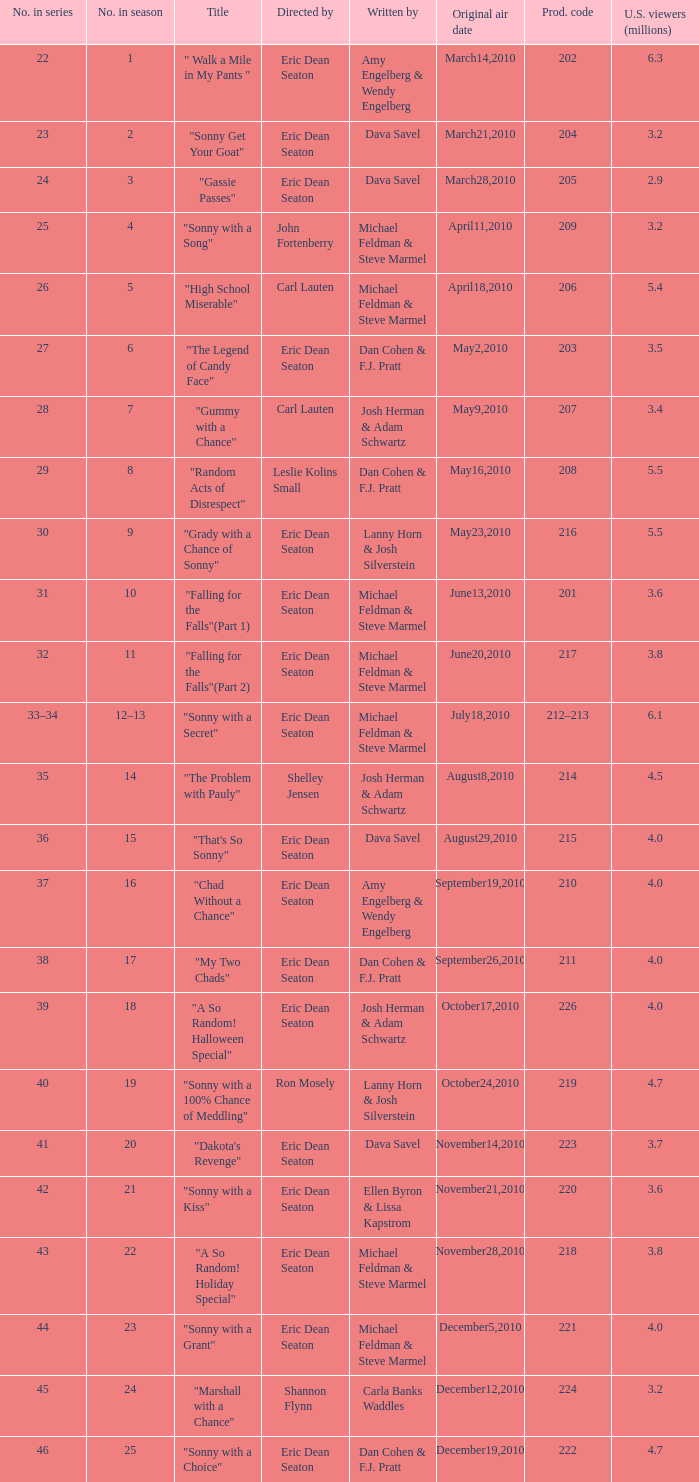Who directed the episode that 6.3 million u.s. viewers saw? Eric Dean Seaton. 